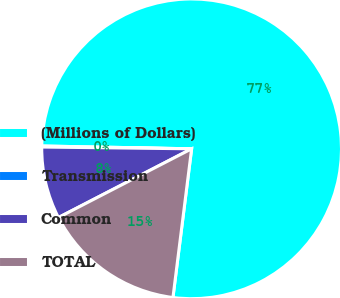Convert chart to OTSL. <chart><loc_0><loc_0><loc_500><loc_500><pie_chart><fcel>(Millions of Dollars)<fcel>Transmission<fcel>Common<fcel>TOTAL<nl><fcel>76.69%<fcel>0.11%<fcel>7.77%<fcel>15.43%<nl></chart> 